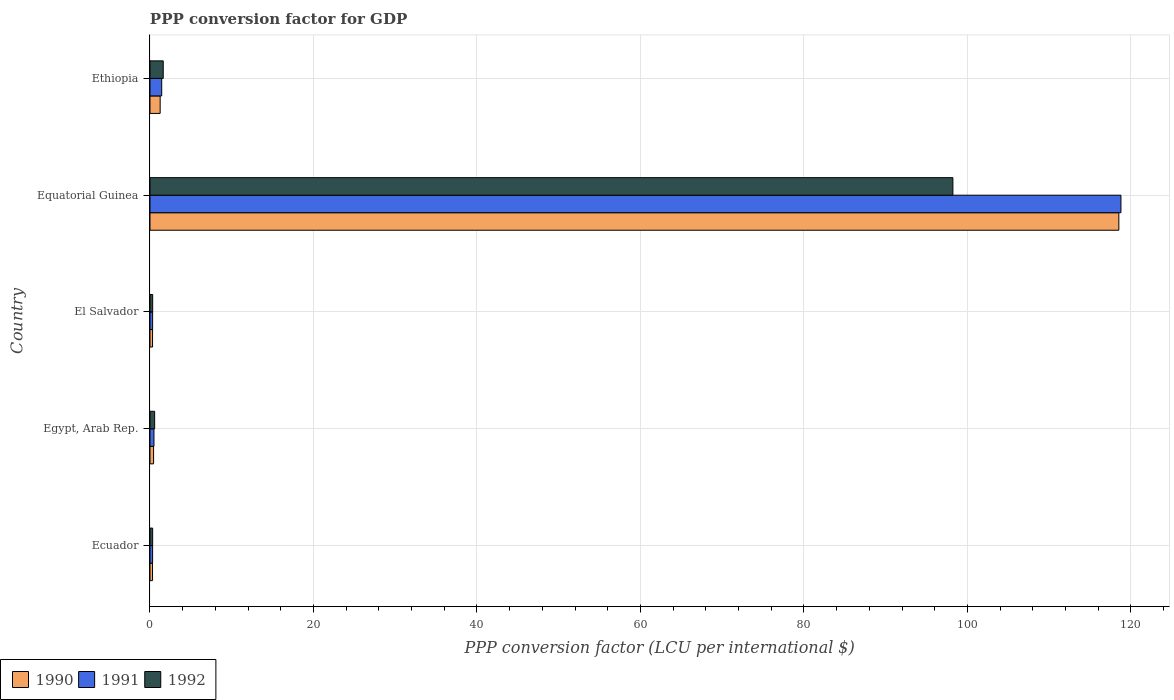How many different coloured bars are there?
Your response must be concise. 3. Are the number of bars on each tick of the Y-axis equal?
Offer a very short reply. Yes. How many bars are there on the 3rd tick from the top?
Ensure brevity in your answer.  3. What is the label of the 1st group of bars from the top?
Ensure brevity in your answer.  Ethiopia. In how many cases, is the number of bars for a given country not equal to the number of legend labels?
Ensure brevity in your answer.  0. What is the PPP conversion factor for GDP in 1992 in Egypt, Arab Rep.?
Keep it short and to the point. 0.57. Across all countries, what is the maximum PPP conversion factor for GDP in 1992?
Make the answer very short. 98.22. Across all countries, what is the minimum PPP conversion factor for GDP in 1991?
Offer a very short reply. 0.32. In which country was the PPP conversion factor for GDP in 1991 maximum?
Your answer should be compact. Equatorial Guinea. In which country was the PPP conversion factor for GDP in 1990 minimum?
Your answer should be compact. Ecuador. What is the total PPP conversion factor for GDP in 1990 in the graph?
Your answer should be compact. 120.82. What is the difference between the PPP conversion factor for GDP in 1990 in Ecuador and that in El Salvador?
Offer a very short reply. -0. What is the difference between the PPP conversion factor for GDP in 1990 in El Salvador and the PPP conversion factor for GDP in 1992 in Ethiopia?
Your response must be concise. -1.31. What is the average PPP conversion factor for GDP in 1991 per country?
Give a very brief answer. 24.27. What is the difference between the PPP conversion factor for GDP in 1991 and PPP conversion factor for GDP in 1990 in Egypt, Arab Rep.?
Provide a short and direct response. 0.05. In how many countries, is the PPP conversion factor for GDP in 1992 greater than 52 LCU?
Provide a succinct answer. 1. What is the ratio of the PPP conversion factor for GDP in 1992 in Ecuador to that in Ethiopia?
Offer a terse response. 0.2. What is the difference between the highest and the second highest PPP conversion factor for GDP in 1992?
Give a very brief answer. 96.6. What is the difference between the highest and the lowest PPP conversion factor for GDP in 1992?
Give a very brief answer. 97.89. In how many countries, is the PPP conversion factor for GDP in 1991 greater than the average PPP conversion factor for GDP in 1991 taken over all countries?
Your answer should be very brief. 1. Is the sum of the PPP conversion factor for GDP in 1990 in Egypt, Arab Rep. and Equatorial Guinea greater than the maximum PPP conversion factor for GDP in 1992 across all countries?
Offer a terse response. Yes. What does the 2nd bar from the top in El Salvador represents?
Your answer should be compact. 1991. How many bars are there?
Provide a short and direct response. 15. Are all the bars in the graph horizontal?
Ensure brevity in your answer.  Yes. Are the values on the major ticks of X-axis written in scientific E-notation?
Make the answer very short. No. Does the graph contain any zero values?
Your response must be concise. No. Where does the legend appear in the graph?
Your response must be concise. Bottom left. How many legend labels are there?
Provide a short and direct response. 3. What is the title of the graph?
Keep it short and to the point. PPP conversion factor for GDP. What is the label or title of the X-axis?
Offer a terse response. PPP conversion factor (LCU per international $). What is the label or title of the Y-axis?
Keep it short and to the point. Country. What is the PPP conversion factor (LCU per international $) in 1990 in Ecuador?
Provide a short and direct response. 0.31. What is the PPP conversion factor (LCU per international $) in 1991 in Ecuador?
Make the answer very short. 0.32. What is the PPP conversion factor (LCU per international $) of 1992 in Ecuador?
Make the answer very short. 0.33. What is the PPP conversion factor (LCU per international $) in 1990 in Egypt, Arab Rep.?
Provide a short and direct response. 0.44. What is the PPP conversion factor (LCU per international $) of 1991 in Egypt, Arab Rep.?
Make the answer very short. 0.49. What is the PPP conversion factor (LCU per international $) in 1992 in Egypt, Arab Rep.?
Offer a very short reply. 0.57. What is the PPP conversion factor (LCU per international $) in 1990 in El Salvador?
Offer a very short reply. 0.31. What is the PPP conversion factor (LCU per international $) of 1991 in El Salvador?
Your response must be concise. 0.32. What is the PPP conversion factor (LCU per international $) in 1992 in El Salvador?
Your answer should be compact. 0.33. What is the PPP conversion factor (LCU per international $) of 1990 in Equatorial Guinea?
Give a very brief answer. 118.52. What is the PPP conversion factor (LCU per international $) in 1991 in Equatorial Guinea?
Offer a terse response. 118.77. What is the PPP conversion factor (LCU per international $) of 1992 in Equatorial Guinea?
Your answer should be compact. 98.22. What is the PPP conversion factor (LCU per international $) in 1990 in Ethiopia?
Offer a very short reply. 1.24. What is the PPP conversion factor (LCU per international $) in 1991 in Ethiopia?
Your answer should be very brief. 1.43. What is the PPP conversion factor (LCU per international $) in 1992 in Ethiopia?
Ensure brevity in your answer.  1.62. Across all countries, what is the maximum PPP conversion factor (LCU per international $) of 1990?
Give a very brief answer. 118.52. Across all countries, what is the maximum PPP conversion factor (LCU per international $) of 1991?
Keep it short and to the point. 118.77. Across all countries, what is the maximum PPP conversion factor (LCU per international $) of 1992?
Provide a short and direct response. 98.22. Across all countries, what is the minimum PPP conversion factor (LCU per international $) in 1990?
Ensure brevity in your answer.  0.31. Across all countries, what is the minimum PPP conversion factor (LCU per international $) in 1991?
Offer a terse response. 0.32. Across all countries, what is the minimum PPP conversion factor (LCU per international $) in 1992?
Give a very brief answer. 0.33. What is the total PPP conversion factor (LCU per international $) of 1990 in the graph?
Make the answer very short. 120.82. What is the total PPP conversion factor (LCU per international $) in 1991 in the graph?
Give a very brief answer. 121.34. What is the total PPP conversion factor (LCU per international $) in 1992 in the graph?
Your answer should be compact. 101.06. What is the difference between the PPP conversion factor (LCU per international $) in 1990 in Ecuador and that in Egypt, Arab Rep.?
Provide a succinct answer. -0.13. What is the difference between the PPP conversion factor (LCU per international $) in 1991 in Ecuador and that in Egypt, Arab Rep.?
Give a very brief answer. -0.17. What is the difference between the PPP conversion factor (LCU per international $) in 1992 in Ecuador and that in Egypt, Arab Rep.?
Ensure brevity in your answer.  -0.24. What is the difference between the PPP conversion factor (LCU per international $) of 1990 in Ecuador and that in El Salvador?
Make the answer very short. -0. What is the difference between the PPP conversion factor (LCU per international $) in 1991 in Ecuador and that in El Salvador?
Offer a terse response. -0. What is the difference between the PPP conversion factor (LCU per international $) of 1992 in Ecuador and that in El Salvador?
Ensure brevity in your answer.  -0. What is the difference between the PPP conversion factor (LCU per international $) in 1990 in Ecuador and that in Equatorial Guinea?
Make the answer very short. -118.21. What is the difference between the PPP conversion factor (LCU per international $) in 1991 in Ecuador and that in Equatorial Guinea?
Make the answer very short. -118.45. What is the difference between the PPP conversion factor (LCU per international $) of 1992 in Ecuador and that in Equatorial Guinea?
Your response must be concise. -97.89. What is the difference between the PPP conversion factor (LCU per international $) in 1990 in Ecuador and that in Ethiopia?
Provide a short and direct response. -0.94. What is the difference between the PPP conversion factor (LCU per international $) of 1991 in Ecuador and that in Ethiopia?
Provide a succinct answer. -1.11. What is the difference between the PPP conversion factor (LCU per international $) of 1992 in Ecuador and that in Ethiopia?
Keep it short and to the point. -1.29. What is the difference between the PPP conversion factor (LCU per international $) in 1990 in Egypt, Arab Rep. and that in El Salvador?
Provide a short and direct response. 0.13. What is the difference between the PPP conversion factor (LCU per international $) of 1991 in Egypt, Arab Rep. and that in El Salvador?
Provide a short and direct response. 0.16. What is the difference between the PPP conversion factor (LCU per international $) in 1992 in Egypt, Arab Rep. and that in El Salvador?
Offer a very short reply. 0.24. What is the difference between the PPP conversion factor (LCU per international $) in 1990 in Egypt, Arab Rep. and that in Equatorial Guinea?
Your answer should be very brief. -118.08. What is the difference between the PPP conversion factor (LCU per international $) in 1991 in Egypt, Arab Rep. and that in Equatorial Guinea?
Your response must be concise. -118.29. What is the difference between the PPP conversion factor (LCU per international $) in 1992 in Egypt, Arab Rep. and that in Equatorial Guinea?
Your response must be concise. -97.65. What is the difference between the PPP conversion factor (LCU per international $) in 1990 in Egypt, Arab Rep. and that in Ethiopia?
Keep it short and to the point. -0.81. What is the difference between the PPP conversion factor (LCU per international $) in 1991 in Egypt, Arab Rep. and that in Ethiopia?
Your answer should be compact. -0.95. What is the difference between the PPP conversion factor (LCU per international $) in 1992 in Egypt, Arab Rep. and that in Ethiopia?
Your answer should be compact. -1.05. What is the difference between the PPP conversion factor (LCU per international $) of 1990 in El Salvador and that in Equatorial Guinea?
Offer a very short reply. -118.21. What is the difference between the PPP conversion factor (LCU per international $) of 1991 in El Salvador and that in Equatorial Guinea?
Your answer should be very brief. -118.45. What is the difference between the PPP conversion factor (LCU per international $) of 1992 in El Salvador and that in Equatorial Guinea?
Your answer should be compact. -97.89. What is the difference between the PPP conversion factor (LCU per international $) in 1990 in El Salvador and that in Ethiopia?
Make the answer very short. -0.93. What is the difference between the PPP conversion factor (LCU per international $) in 1991 in El Salvador and that in Ethiopia?
Your answer should be very brief. -1.11. What is the difference between the PPP conversion factor (LCU per international $) in 1992 in El Salvador and that in Ethiopia?
Offer a very short reply. -1.29. What is the difference between the PPP conversion factor (LCU per international $) in 1990 in Equatorial Guinea and that in Ethiopia?
Offer a terse response. 117.27. What is the difference between the PPP conversion factor (LCU per international $) in 1991 in Equatorial Guinea and that in Ethiopia?
Provide a short and direct response. 117.34. What is the difference between the PPP conversion factor (LCU per international $) of 1992 in Equatorial Guinea and that in Ethiopia?
Make the answer very short. 96.6. What is the difference between the PPP conversion factor (LCU per international $) of 1990 in Ecuador and the PPP conversion factor (LCU per international $) of 1991 in Egypt, Arab Rep.?
Your answer should be compact. -0.18. What is the difference between the PPP conversion factor (LCU per international $) of 1990 in Ecuador and the PPP conversion factor (LCU per international $) of 1992 in Egypt, Arab Rep.?
Provide a short and direct response. -0.26. What is the difference between the PPP conversion factor (LCU per international $) in 1991 in Ecuador and the PPP conversion factor (LCU per international $) in 1992 in Egypt, Arab Rep.?
Your response must be concise. -0.25. What is the difference between the PPP conversion factor (LCU per international $) of 1990 in Ecuador and the PPP conversion factor (LCU per international $) of 1991 in El Salvador?
Offer a very short reply. -0.01. What is the difference between the PPP conversion factor (LCU per international $) in 1990 in Ecuador and the PPP conversion factor (LCU per international $) in 1992 in El Salvador?
Offer a very short reply. -0.02. What is the difference between the PPP conversion factor (LCU per international $) in 1991 in Ecuador and the PPP conversion factor (LCU per international $) in 1992 in El Salvador?
Give a very brief answer. -0.01. What is the difference between the PPP conversion factor (LCU per international $) of 1990 in Ecuador and the PPP conversion factor (LCU per international $) of 1991 in Equatorial Guinea?
Ensure brevity in your answer.  -118.47. What is the difference between the PPP conversion factor (LCU per international $) of 1990 in Ecuador and the PPP conversion factor (LCU per international $) of 1992 in Equatorial Guinea?
Ensure brevity in your answer.  -97.91. What is the difference between the PPP conversion factor (LCU per international $) of 1991 in Ecuador and the PPP conversion factor (LCU per international $) of 1992 in Equatorial Guinea?
Your response must be concise. -97.9. What is the difference between the PPP conversion factor (LCU per international $) of 1990 in Ecuador and the PPP conversion factor (LCU per international $) of 1991 in Ethiopia?
Offer a very short reply. -1.12. What is the difference between the PPP conversion factor (LCU per international $) of 1990 in Ecuador and the PPP conversion factor (LCU per international $) of 1992 in Ethiopia?
Your answer should be very brief. -1.31. What is the difference between the PPP conversion factor (LCU per international $) in 1991 in Ecuador and the PPP conversion factor (LCU per international $) in 1992 in Ethiopia?
Ensure brevity in your answer.  -1.3. What is the difference between the PPP conversion factor (LCU per international $) in 1990 in Egypt, Arab Rep. and the PPP conversion factor (LCU per international $) in 1991 in El Salvador?
Provide a succinct answer. 0.12. What is the difference between the PPP conversion factor (LCU per international $) in 1990 in Egypt, Arab Rep. and the PPP conversion factor (LCU per international $) in 1992 in El Salvador?
Your response must be concise. 0.11. What is the difference between the PPP conversion factor (LCU per international $) of 1991 in Egypt, Arab Rep. and the PPP conversion factor (LCU per international $) of 1992 in El Salvador?
Keep it short and to the point. 0.16. What is the difference between the PPP conversion factor (LCU per international $) of 1990 in Egypt, Arab Rep. and the PPP conversion factor (LCU per international $) of 1991 in Equatorial Guinea?
Keep it short and to the point. -118.34. What is the difference between the PPP conversion factor (LCU per international $) of 1990 in Egypt, Arab Rep. and the PPP conversion factor (LCU per international $) of 1992 in Equatorial Guinea?
Your answer should be very brief. -97.78. What is the difference between the PPP conversion factor (LCU per international $) in 1991 in Egypt, Arab Rep. and the PPP conversion factor (LCU per international $) in 1992 in Equatorial Guinea?
Ensure brevity in your answer.  -97.73. What is the difference between the PPP conversion factor (LCU per international $) of 1990 in Egypt, Arab Rep. and the PPP conversion factor (LCU per international $) of 1991 in Ethiopia?
Offer a terse response. -0.99. What is the difference between the PPP conversion factor (LCU per international $) in 1990 in Egypt, Arab Rep. and the PPP conversion factor (LCU per international $) in 1992 in Ethiopia?
Ensure brevity in your answer.  -1.18. What is the difference between the PPP conversion factor (LCU per international $) of 1991 in Egypt, Arab Rep. and the PPP conversion factor (LCU per international $) of 1992 in Ethiopia?
Make the answer very short. -1.13. What is the difference between the PPP conversion factor (LCU per international $) in 1990 in El Salvador and the PPP conversion factor (LCU per international $) in 1991 in Equatorial Guinea?
Make the answer very short. -118.46. What is the difference between the PPP conversion factor (LCU per international $) in 1990 in El Salvador and the PPP conversion factor (LCU per international $) in 1992 in Equatorial Guinea?
Your answer should be very brief. -97.9. What is the difference between the PPP conversion factor (LCU per international $) in 1991 in El Salvador and the PPP conversion factor (LCU per international $) in 1992 in Equatorial Guinea?
Ensure brevity in your answer.  -97.89. What is the difference between the PPP conversion factor (LCU per international $) of 1990 in El Salvador and the PPP conversion factor (LCU per international $) of 1991 in Ethiopia?
Provide a short and direct response. -1.12. What is the difference between the PPP conversion factor (LCU per international $) in 1990 in El Salvador and the PPP conversion factor (LCU per international $) in 1992 in Ethiopia?
Give a very brief answer. -1.31. What is the difference between the PPP conversion factor (LCU per international $) in 1991 in El Salvador and the PPP conversion factor (LCU per international $) in 1992 in Ethiopia?
Your response must be concise. -1.3. What is the difference between the PPP conversion factor (LCU per international $) in 1990 in Equatorial Guinea and the PPP conversion factor (LCU per international $) in 1991 in Ethiopia?
Your response must be concise. 117.08. What is the difference between the PPP conversion factor (LCU per international $) of 1990 in Equatorial Guinea and the PPP conversion factor (LCU per international $) of 1992 in Ethiopia?
Your answer should be compact. 116.9. What is the difference between the PPP conversion factor (LCU per international $) of 1991 in Equatorial Guinea and the PPP conversion factor (LCU per international $) of 1992 in Ethiopia?
Give a very brief answer. 117.16. What is the average PPP conversion factor (LCU per international $) in 1990 per country?
Make the answer very short. 24.16. What is the average PPP conversion factor (LCU per international $) of 1991 per country?
Your response must be concise. 24.27. What is the average PPP conversion factor (LCU per international $) of 1992 per country?
Keep it short and to the point. 20.21. What is the difference between the PPP conversion factor (LCU per international $) in 1990 and PPP conversion factor (LCU per international $) in 1991 in Ecuador?
Keep it short and to the point. -0.01. What is the difference between the PPP conversion factor (LCU per international $) of 1990 and PPP conversion factor (LCU per international $) of 1992 in Ecuador?
Your answer should be very brief. -0.02. What is the difference between the PPP conversion factor (LCU per international $) of 1991 and PPP conversion factor (LCU per international $) of 1992 in Ecuador?
Give a very brief answer. -0.01. What is the difference between the PPP conversion factor (LCU per international $) in 1990 and PPP conversion factor (LCU per international $) in 1991 in Egypt, Arab Rep.?
Provide a succinct answer. -0.05. What is the difference between the PPP conversion factor (LCU per international $) in 1990 and PPP conversion factor (LCU per international $) in 1992 in Egypt, Arab Rep.?
Keep it short and to the point. -0.13. What is the difference between the PPP conversion factor (LCU per international $) of 1991 and PPP conversion factor (LCU per international $) of 1992 in Egypt, Arab Rep.?
Your answer should be very brief. -0.08. What is the difference between the PPP conversion factor (LCU per international $) in 1990 and PPP conversion factor (LCU per international $) in 1991 in El Salvador?
Provide a short and direct response. -0.01. What is the difference between the PPP conversion factor (LCU per international $) in 1990 and PPP conversion factor (LCU per international $) in 1992 in El Salvador?
Give a very brief answer. -0.02. What is the difference between the PPP conversion factor (LCU per international $) in 1991 and PPP conversion factor (LCU per international $) in 1992 in El Salvador?
Make the answer very short. -0.01. What is the difference between the PPP conversion factor (LCU per international $) in 1990 and PPP conversion factor (LCU per international $) in 1991 in Equatorial Guinea?
Ensure brevity in your answer.  -0.26. What is the difference between the PPP conversion factor (LCU per international $) in 1990 and PPP conversion factor (LCU per international $) in 1992 in Equatorial Guinea?
Your response must be concise. 20.3. What is the difference between the PPP conversion factor (LCU per international $) of 1991 and PPP conversion factor (LCU per international $) of 1992 in Equatorial Guinea?
Keep it short and to the point. 20.56. What is the difference between the PPP conversion factor (LCU per international $) of 1990 and PPP conversion factor (LCU per international $) of 1991 in Ethiopia?
Your answer should be very brief. -0.19. What is the difference between the PPP conversion factor (LCU per international $) in 1990 and PPP conversion factor (LCU per international $) in 1992 in Ethiopia?
Offer a very short reply. -0.38. What is the difference between the PPP conversion factor (LCU per international $) in 1991 and PPP conversion factor (LCU per international $) in 1992 in Ethiopia?
Your response must be concise. -0.19. What is the ratio of the PPP conversion factor (LCU per international $) in 1990 in Ecuador to that in Egypt, Arab Rep.?
Your answer should be very brief. 0.7. What is the ratio of the PPP conversion factor (LCU per international $) in 1991 in Ecuador to that in Egypt, Arab Rep.?
Ensure brevity in your answer.  0.66. What is the ratio of the PPP conversion factor (LCU per international $) of 1992 in Ecuador to that in Egypt, Arab Rep.?
Offer a terse response. 0.57. What is the ratio of the PPP conversion factor (LCU per international $) in 1990 in Ecuador to that in El Salvador?
Your answer should be compact. 0.99. What is the ratio of the PPP conversion factor (LCU per international $) of 1991 in Ecuador to that in El Salvador?
Provide a succinct answer. 0.99. What is the ratio of the PPP conversion factor (LCU per international $) of 1990 in Ecuador to that in Equatorial Guinea?
Keep it short and to the point. 0. What is the ratio of the PPP conversion factor (LCU per international $) in 1991 in Ecuador to that in Equatorial Guinea?
Ensure brevity in your answer.  0. What is the ratio of the PPP conversion factor (LCU per international $) of 1992 in Ecuador to that in Equatorial Guinea?
Offer a terse response. 0. What is the ratio of the PPP conversion factor (LCU per international $) of 1990 in Ecuador to that in Ethiopia?
Provide a short and direct response. 0.25. What is the ratio of the PPP conversion factor (LCU per international $) of 1991 in Ecuador to that in Ethiopia?
Keep it short and to the point. 0.22. What is the ratio of the PPP conversion factor (LCU per international $) of 1992 in Ecuador to that in Ethiopia?
Provide a short and direct response. 0.2. What is the ratio of the PPP conversion factor (LCU per international $) in 1990 in Egypt, Arab Rep. to that in El Salvador?
Provide a short and direct response. 1.41. What is the ratio of the PPP conversion factor (LCU per international $) of 1991 in Egypt, Arab Rep. to that in El Salvador?
Your answer should be very brief. 1.51. What is the ratio of the PPP conversion factor (LCU per international $) of 1992 in Egypt, Arab Rep. to that in El Salvador?
Your answer should be compact. 1.73. What is the ratio of the PPP conversion factor (LCU per international $) of 1990 in Egypt, Arab Rep. to that in Equatorial Guinea?
Your answer should be compact. 0. What is the ratio of the PPP conversion factor (LCU per international $) of 1991 in Egypt, Arab Rep. to that in Equatorial Guinea?
Ensure brevity in your answer.  0. What is the ratio of the PPP conversion factor (LCU per international $) of 1992 in Egypt, Arab Rep. to that in Equatorial Guinea?
Your answer should be compact. 0.01. What is the ratio of the PPP conversion factor (LCU per international $) of 1990 in Egypt, Arab Rep. to that in Ethiopia?
Your response must be concise. 0.35. What is the ratio of the PPP conversion factor (LCU per international $) of 1991 in Egypt, Arab Rep. to that in Ethiopia?
Offer a very short reply. 0.34. What is the ratio of the PPP conversion factor (LCU per international $) of 1992 in Egypt, Arab Rep. to that in Ethiopia?
Offer a terse response. 0.35. What is the ratio of the PPP conversion factor (LCU per international $) in 1990 in El Salvador to that in Equatorial Guinea?
Offer a terse response. 0. What is the ratio of the PPP conversion factor (LCU per international $) in 1991 in El Salvador to that in Equatorial Guinea?
Provide a succinct answer. 0. What is the ratio of the PPP conversion factor (LCU per international $) in 1992 in El Salvador to that in Equatorial Guinea?
Keep it short and to the point. 0. What is the ratio of the PPP conversion factor (LCU per international $) of 1990 in El Salvador to that in Ethiopia?
Give a very brief answer. 0.25. What is the ratio of the PPP conversion factor (LCU per international $) of 1991 in El Salvador to that in Ethiopia?
Your response must be concise. 0.23. What is the ratio of the PPP conversion factor (LCU per international $) of 1992 in El Salvador to that in Ethiopia?
Give a very brief answer. 0.2. What is the ratio of the PPP conversion factor (LCU per international $) in 1990 in Equatorial Guinea to that in Ethiopia?
Give a very brief answer. 95.29. What is the ratio of the PPP conversion factor (LCU per international $) in 1991 in Equatorial Guinea to that in Ethiopia?
Provide a short and direct response. 82.86. What is the ratio of the PPP conversion factor (LCU per international $) in 1992 in Equatorial Guinea to that in Ethiopia?
Offer a terse response. 60.66. What is the difference between the highest and the second highest PPP conversion factor (LCU per international $) in 1990?
Provide a succinct answer. 117.27. What is the difference between the highest and the second highest PPP conversion factor (LCU per international $) in 1991?
Offer a very short reply. 117.34. What is the difference between the highest and the second highest PPP conversion factor (LCU per international $) of 1992?
Provide a short and direct response. 96.6. What is the difference between the highest and the lowest PPP conversion factor (LCU per international $) in 1990?
Your answer should be compact. 118.21. What is the difference between the highest and the lowest PPP conversion factor (LCU per international $) in 1991?
Make the answer very short. 118.45. What is the difference between the highest and the lowest PPP conversion factor (LCU per international $) in 1992?
Ensure brevity in your answer.  97.89. 